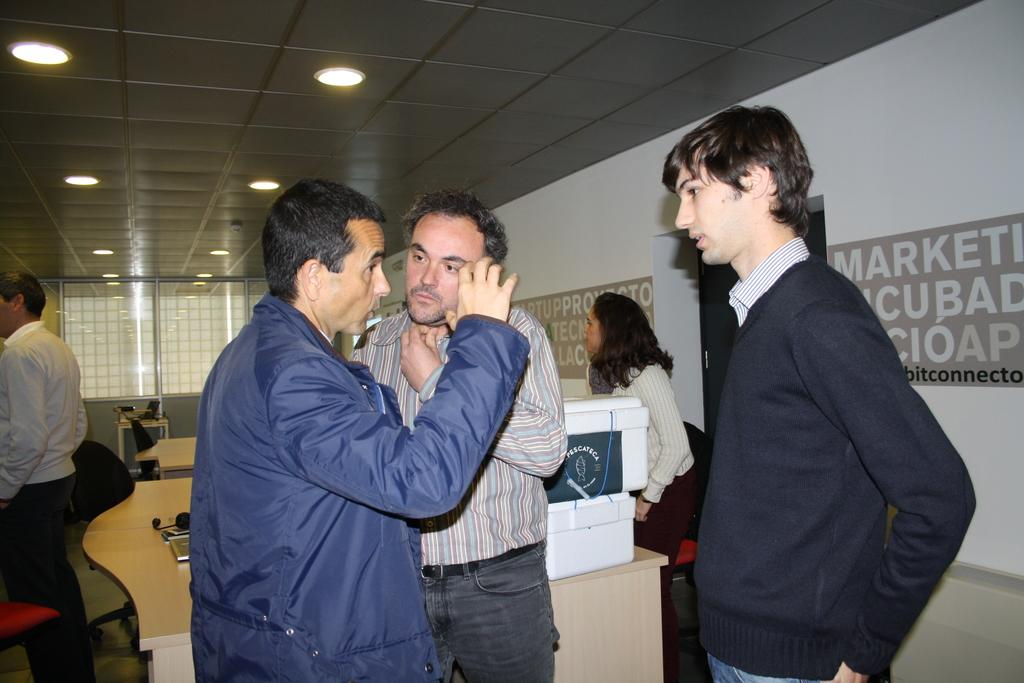How many people are in the image? There is a group of people in the image, but the exact number is not specified. What is the position of the people in the image? The people are standing on the floor in the image. What type of furniture is present in the image? There are tables and chairs in the image. What objects are visible on the floor in the image? Boxes are visible in the image. What is hanging on the wall in the image? Banners are on the wall in the image. What can be seen in the background of the image? Lights are visible in the background of the image. What historical event is being commemorated by the wave of nerves in the image? There is no mention of a historical event, wave, or nerves in the image. The image features a group of people, tables, chairs, boxes, banners, and lights. 